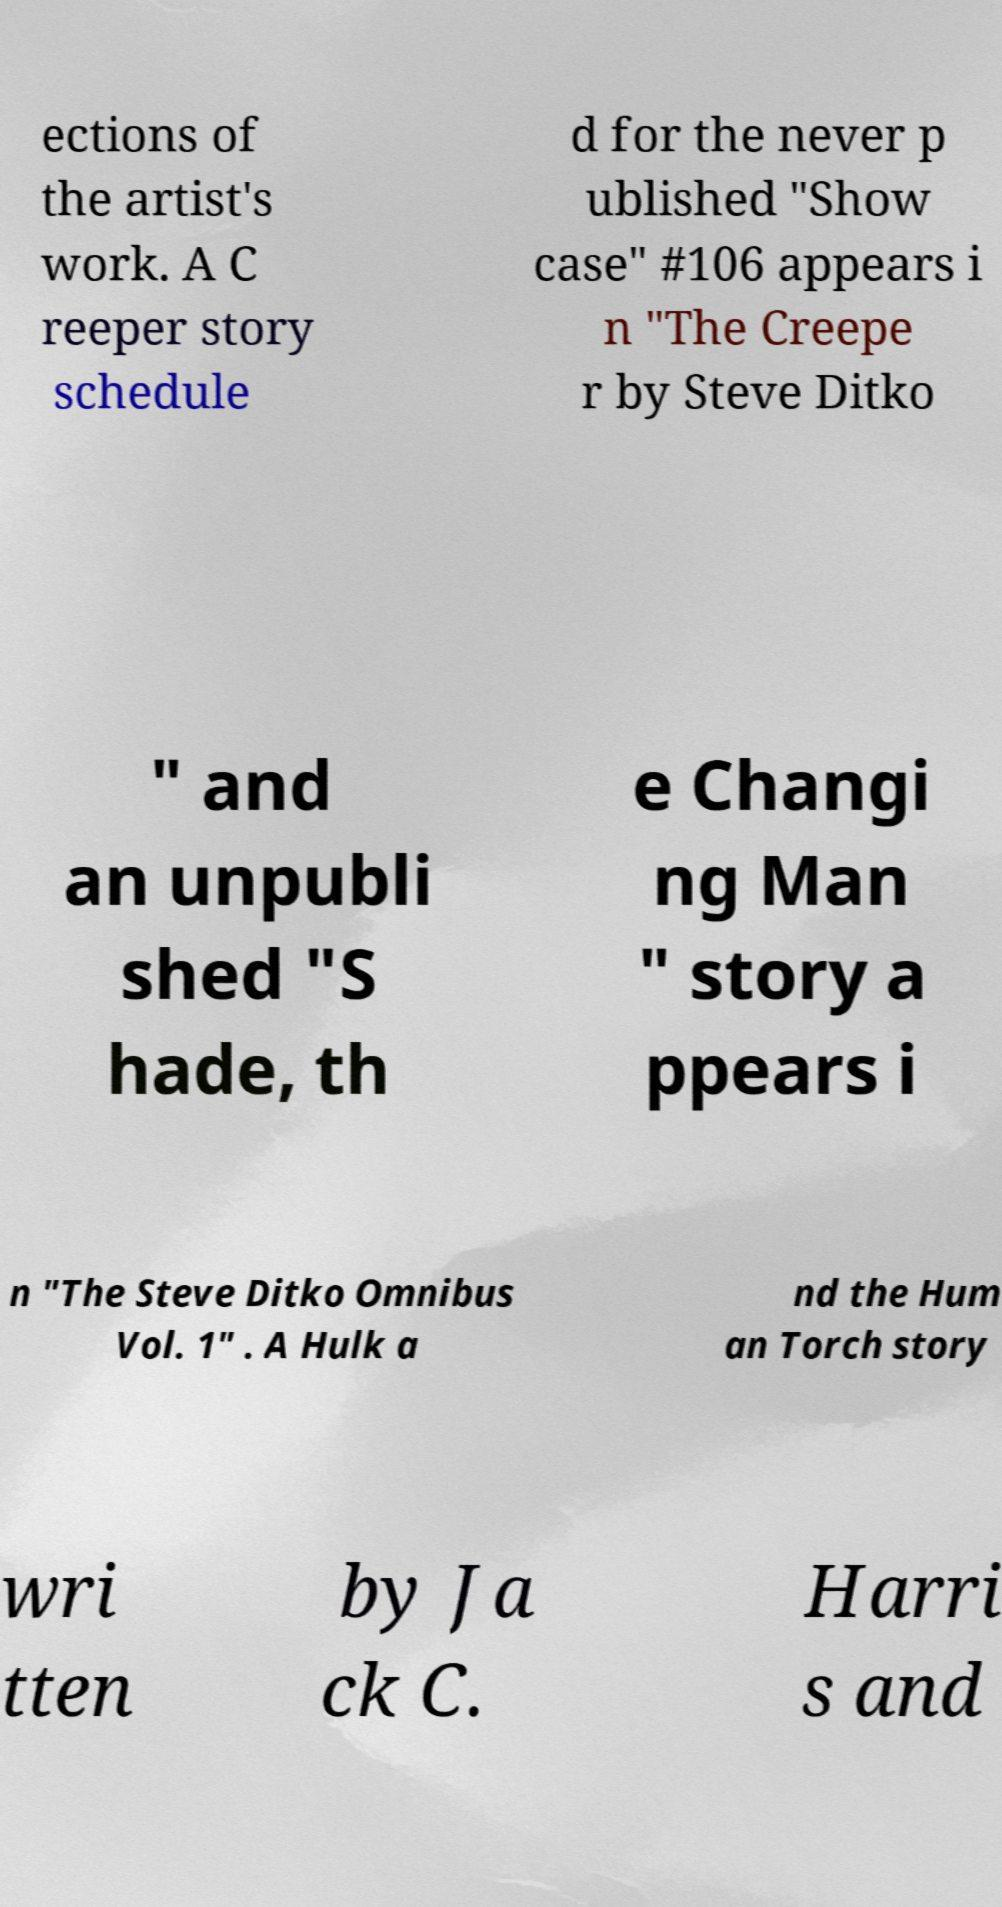Could you extract and type out the text from this image? ections of the artist's work. A C reeper story schedule d for the never p ublished "Show case" #106 appears i n "The Creepe r by Steve Ditko " and an unpubli shed "S hade, th e Changi ng Man " story a ppears i n "The Steve Ditko Omnibus Vol. 1" . A Hulk a nd the Hum an Torch story wri tten by Ja ck C. Harri s and 